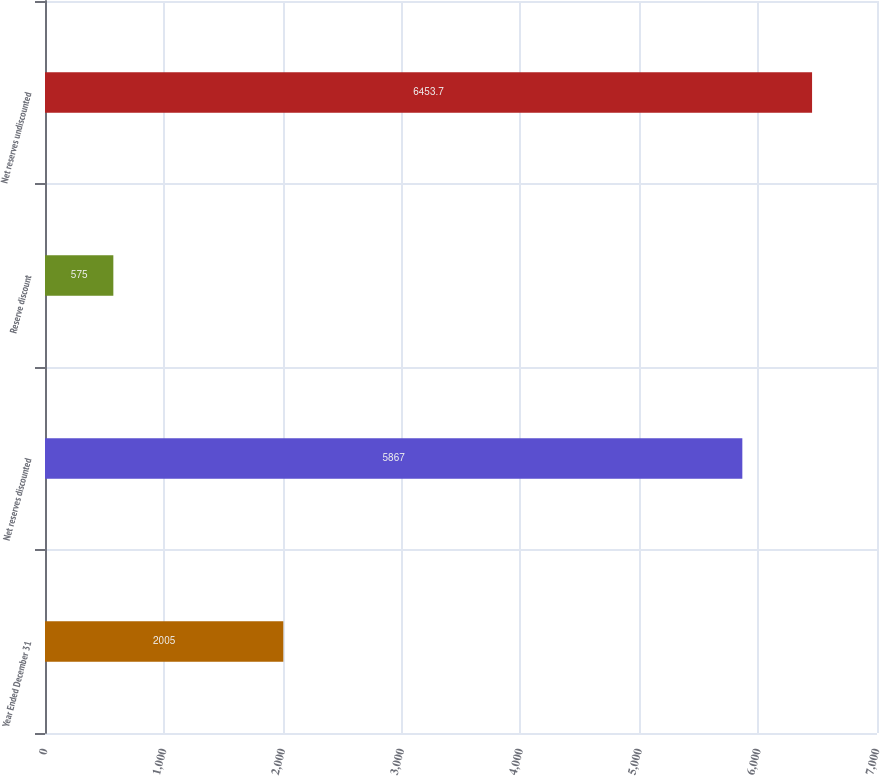<chart> <loc_0><loc_0><loc_500><loc_500><bar_chart><fcel>Year Ended December 31<fcel>Net reserves discounted<fcel>Reserve discount<fcel>Net reserves undiscounted<nl><fcel>2005<fcel>5867<fcel>575<fcel>6453.7<nl></chart> 